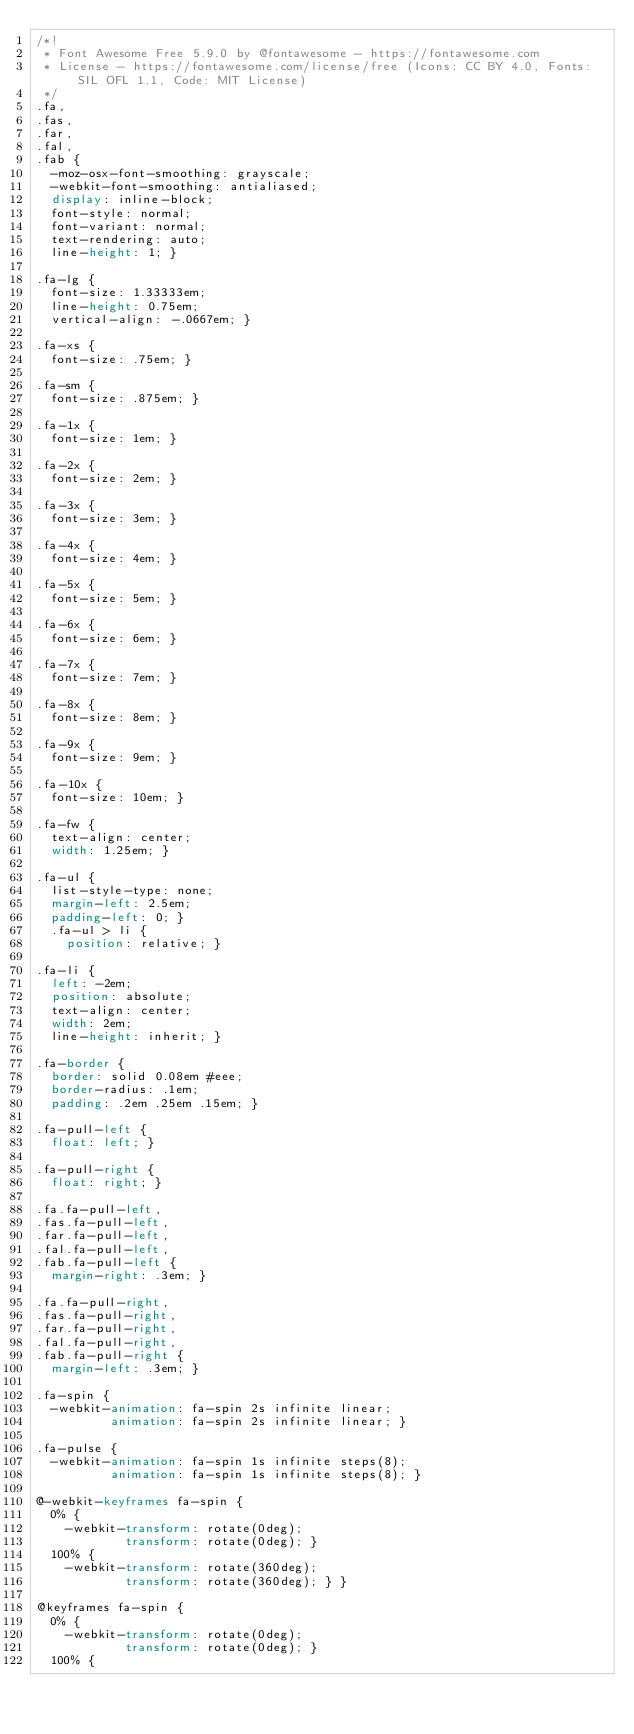Convert code to text. <code><loc_0><loc_0><loc_500><loc_500><_CSS_>/*!
 * Font Awesome Free 5.9.0 by @fontawesome - https://fontawesome.com
 * License - https://fontawesome.com/license/free (Icons: CC BY 4.0, Fonts: SIL OFL 1.1, Code: MIT License)
 */
.fa,
.fas,
.far,
.fal,
.fab {
  -moz-osx-font-smoothing: grayscale;
  -webkit-font-smoothing: antialiased;
  display: inline-block;
  font-style: normal;
  font-variant: normal;
  text-rendering: auto;
  line-height: 1; }

.fa-lg {
  font-size: 1.33333em;
  line-height: 0.75em;
  vertical-align: -.0667em; }

.fa-xs {
  font-size: .75em; }

.fa-sm {
  font-size: .875em; }

.fa-1x {
  font-size: 1em; }

.fa-2x {
  font-size: 2em; }

.fa-3x {
  font-size: 3em; }

.fa-4x {
  font-size: 4em; }

.fa-5x {
  font-size: 5em; }

.fa-6x {
  font-size: 6em; }

.fa-7x {
  font-size: 7em; }

.fa-8x {
  font-size: 8em; }

.fa-9x {
  font-size: 9em; }

.fa-10x {
  font-size: 10em; }

.fa-fw {
  text-align: center;
  width: 1.25em; }

.fa-ul {
  list-style-type: none;
  margin-left: 2.5em;
  padding-left: 0; }
  .fa-ul > li {
    position: relative; }

.fa-li {
  left: -2em;
  position: absolute;
  text-align: center;
  width: 2em;
  line-height: inherit; }

.fa-border {
  border: solid 0.08em #eee;
  border-radius: .1em;
  padding: .2em .25em .15em; }

.fa-pull-left {
  float: left; }

.fa-pull-right {
  float: right; }

.fa.fa-pull-left,
.fas.fa-pull-left,
.far.fa-pull-left,
.fal.fa-pull-left,
.fab.fa-pull-left {
  margin-right: .3em; }

.fa.fa-pull-right,
.fas.fa-pull-right,
.far.fa-pull-right,
.fal.fa-pull-right,
.fab.fa-pull-right {
  margin-left: .3em; }

.fa-spin {
  -webkit-animation: fa-spin 2s infinite linear;
          animation: fa-spin 2s infinite linear; }

.fa-pulse {
  -webkit-animation: fa-spin 1s infinite steps(8);
          animation: fa-spin 1s infinite steps(8); }

@-webkit-keyframes fa-spin {
  0% {
    -webkit-transform: rotate(0deg);
            transform: rotate(0deg); }
  100% {
    -webkit-transform: rotate(360deg);
            transform: rotate(360deg); } }

@keyframes fa-spin {
  0% {
    -webkit-transform: rotate(0deg);
            transform: rotate(0deg); }
  100% {</code> 